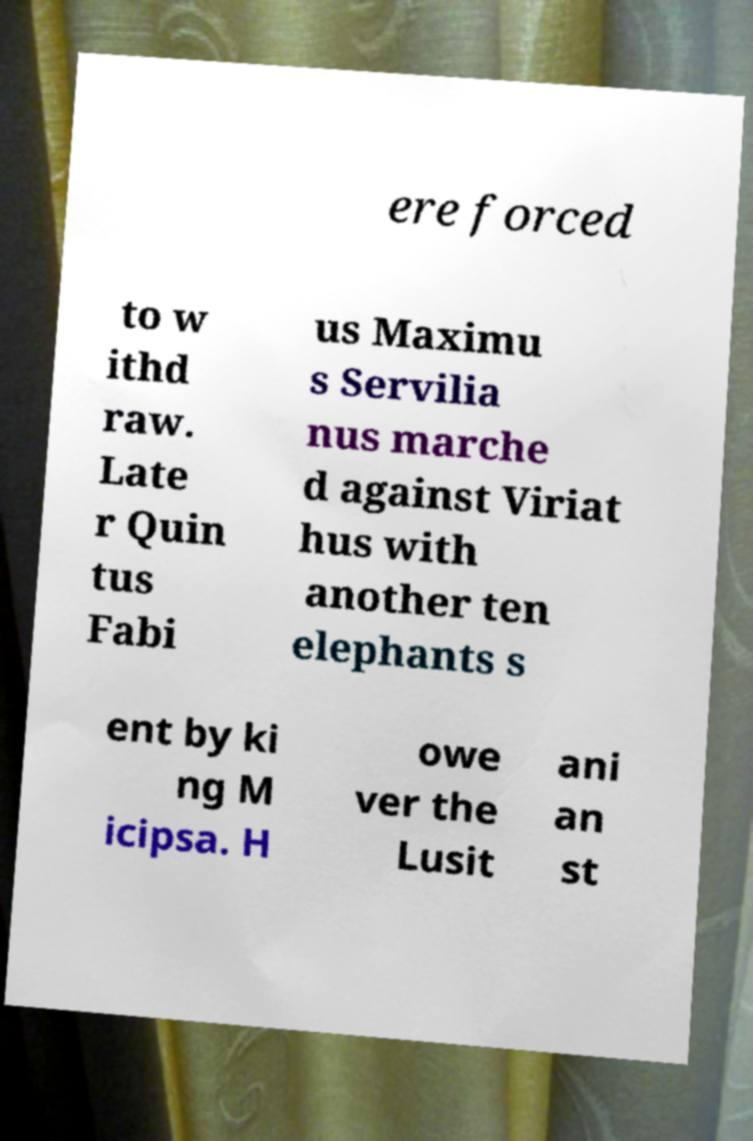There's text embedded in this image that I need extracted. Can you transcribe it verbatim? ere forced to w ithd raw. Late r Quin tus Fabi us Maximu s Servilia nus marche d against Viriat hus with another ten elephants s ent by ki ng M icipsa. H owe ver the Lusit ani an st 